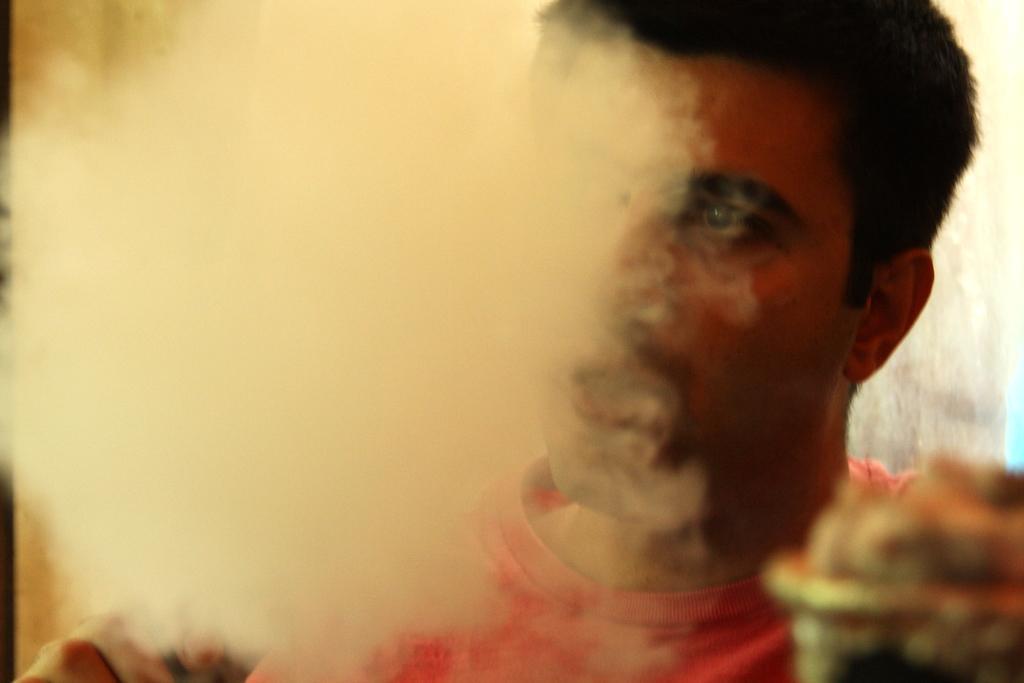In one or two sentences, can you explain what this image depicts? This is a close up image of a man wearing clothes and we can see smoke. 